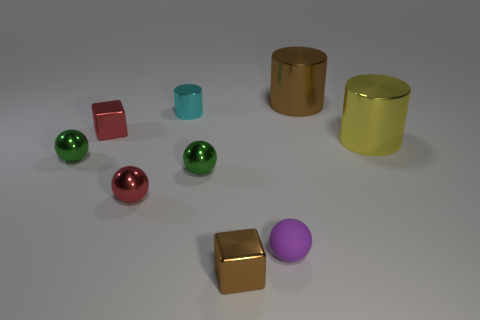Subtract all balls. How many objects are left? 5 Add 4 yellow cylinders. How many yellow cylinders are left? 5 Add 2 rubber blocks. How many rubber blocks exist? 2 Subtract 0 cyan cubes. How many objects are left? 9 Subtract all large brown things. Subtract all tiny green objects. How many objects are left? 6 